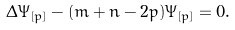<formula> <loc_0><loc_0><loc_500><loc_500>\Delta \Psi _ { [ p ] } - ( m + n - 2 p ) \Psi _ { [ p ] } = 0 .</formula> 